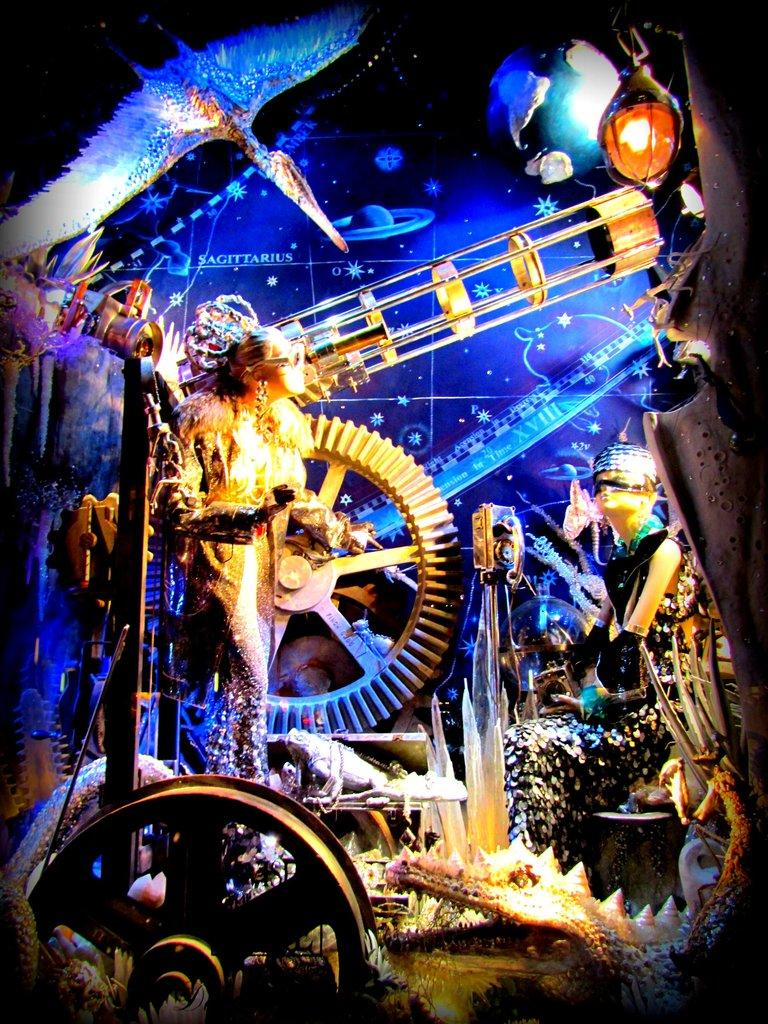What type of picture is in the image? The image contains an animation picture. What is one object that can be seen in the image? There is a statue in the image. What is another object that can be seen in the image? There is a wheel in the image. What is a third object that can be seen in the image? There is a globe in the image. What is a source of illumination in the image? There is a light in the image. What type of living creature is on the ground in the image? There is an animal on the ground in the image. What channel is the animal watching on the ground in the image? There is no television or channel present in the image; it only shows an animal on the ground. What type of nut is being cracked by the statue in the image? There is no nut or any activity involving a nut in the image; the statue is simply a stationary object. 